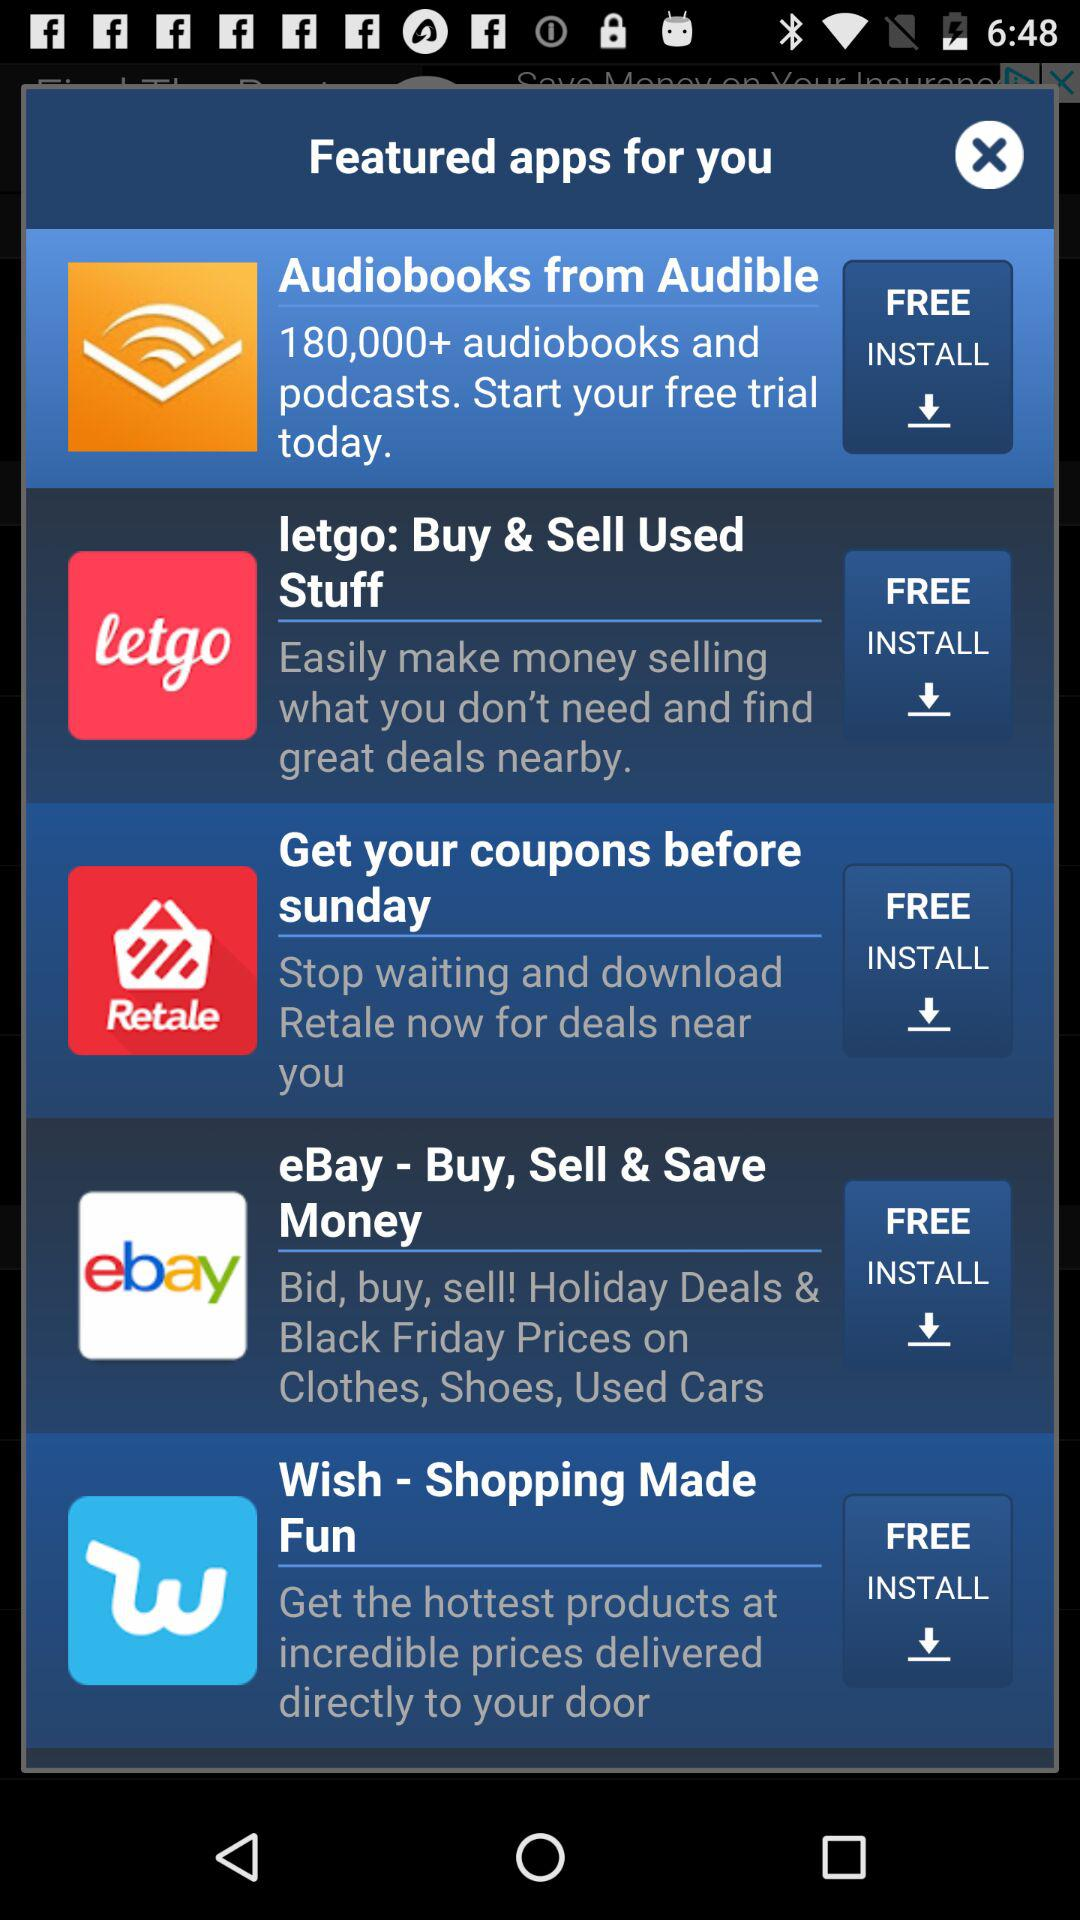How many featured apps are there?
Answer the question using a single word or phrase. 5 